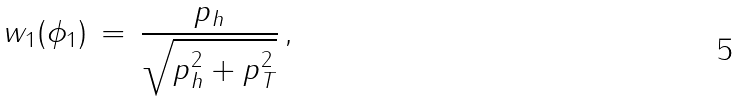<formula> <loc_0><loc_0><loc_500><loc_500>w _ { 1 } ( \phi _ { 1 } ) \, = \, \frac { p _ { h } } { \sqrt { p _ { h } ^ { 2 } + p _ { T } ^ { 2 } } } \, ,</formula> 